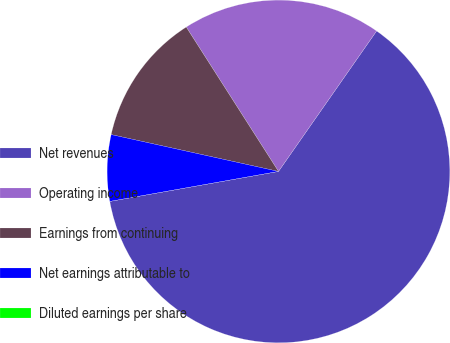Convert chart. <chart><loc_0><loc_0><loc_500><loc_500><pie_chart><fcel>Net revenues<fcel>Operating income<fcel>Earnings from continuing<fcel>Net earnings attributable to<fcel>Diluted earnings per share<nl><fcel>62.49%<fcel>18.75%<fcel>12.5%<fcel>6.25%<fcel>0.0%<nl></chart> 